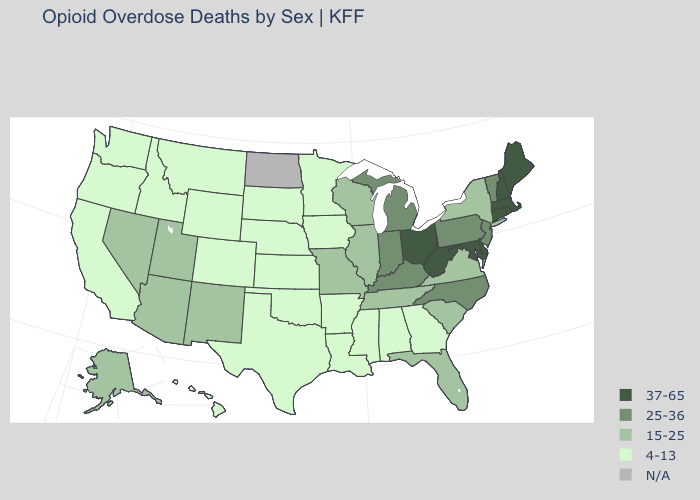What is the value of West Virginia?
Give a very brief answer. 37-65. What is the value of Louisiana?
Keep it brief. 4-13. Which states have the highest value in the USA?
Be succinct. Connecticut, Delaware, Maine, Maryland, Massachusetts, New Hampshire, Ohio, Rhode Island, West Virginia. What is the highest value in the Northeast ?
Answer briefly. 37-65. What is the value of North Carolina?
Keep it brief. 25-36. What is the value of Illinois?
Give a very brief answer. 15-25. What is the highest value in the South ?
Write a very short answer. 37-65. Name the states that have a value in the range 15-25?
Write a very short answer. Alaska, Arizona, Florida, Illinois, Missouri, Nevada, New Mexico, New York, South Carolina, Tennessee, Utah, Virginia, Wisconsin. Name the states that have a value in the range 15-25?
Answer briefly. Alaska, Arizona, Florida, Illinois, Missouri, Nevada, New Mexico, New York, South Carolina, Tennessee, Utah, Virginia, Wisconsin. Name the states that have a value in the range 15-25?
Give a very brief answer. Alaska, Arizona, Florida, Illinois, Missouri, Nevada, New Mexico, New York, South Carolina, Tennessee, Utah, Virginia, Wisconsin. What is the value of Mississippi?
Answer briefly. 4-13. What is the value of West Virginia?
Give a very brief answer. 37-65. Which states have the highest value in the USA?
Keep it brief. Connecticut, Delaware, Maine, Maryland, Massachusetts, New Hampshire, Ohio, Rhode Island, West Virginia. 